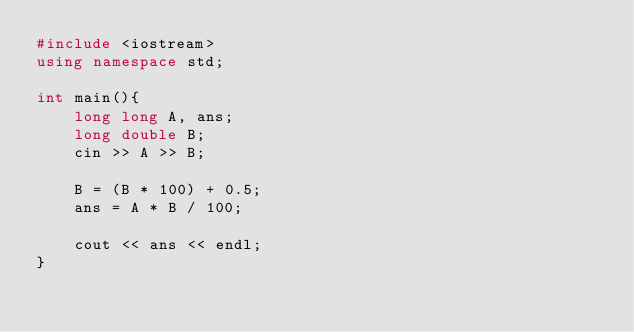Convert code to text. <code><loc_0><loc_0><loc_500><loc_500><_C++_>#include <iostream>
using namespace std;

int main(){
    long long A, ans;
    long double B;
    cin >> A >> B;

    B = (B * 100) + 0.5;
    ans = A * B / 100;
    
    cout << ans << endl;
}</code> 